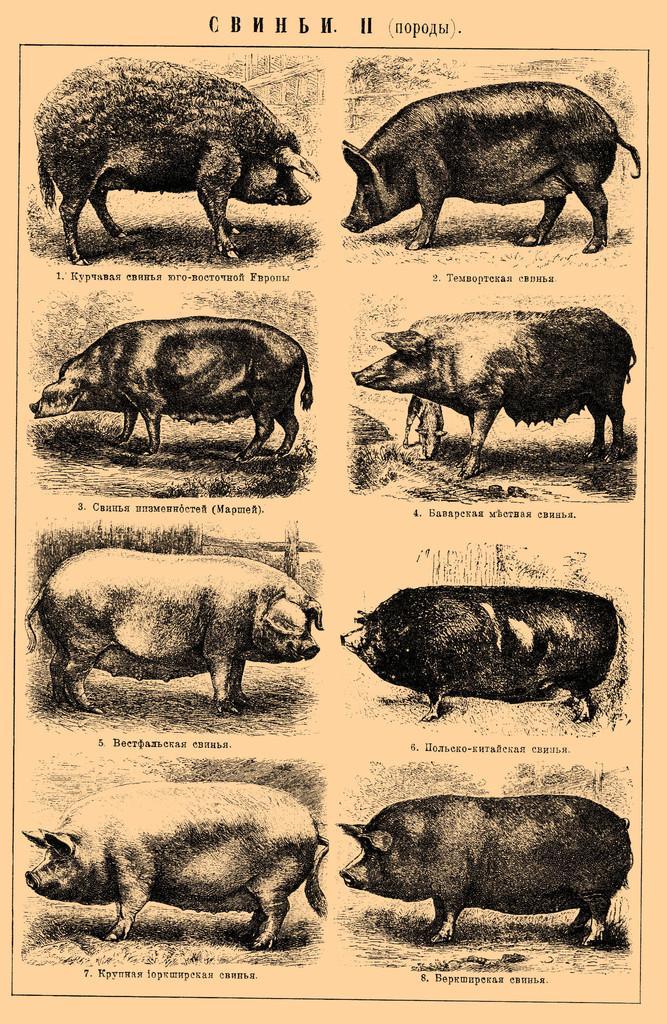Could you give a brief overview of what you see in this image? This picture shows a paper and we see types of pigs and text on it. 